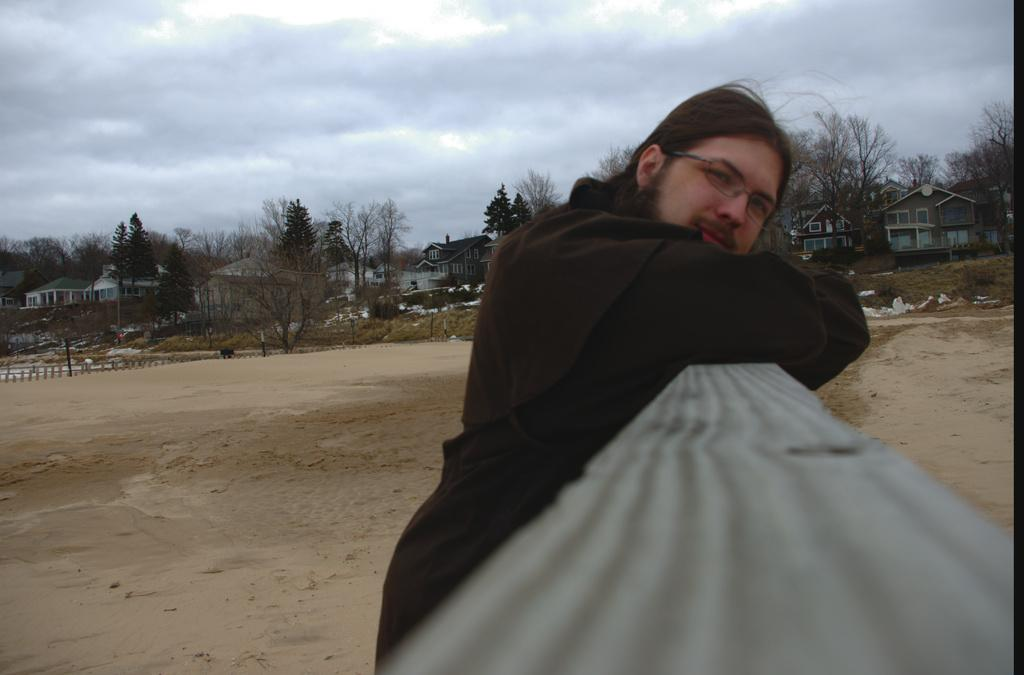What is the main subject of the image? There is a person in the image. What is the person doing in the image? The person is resting his hands on an object. What type of surface is visible beneath the person? There is ground visible in the image. What type of vegetation is present on the ground? Plants are present on the ground. What other natural elements can be seen in the image? Trees are visible in the image. What man-made structures are present in the image? Poles and a building with windows are present in the image. What is visible in the background of the image? The sky is visible in the image, and clouds are present in the sky. What type of scent can be detected from the bed in the image? There is no bed present in the image, so it is not possible to detect any scent. 